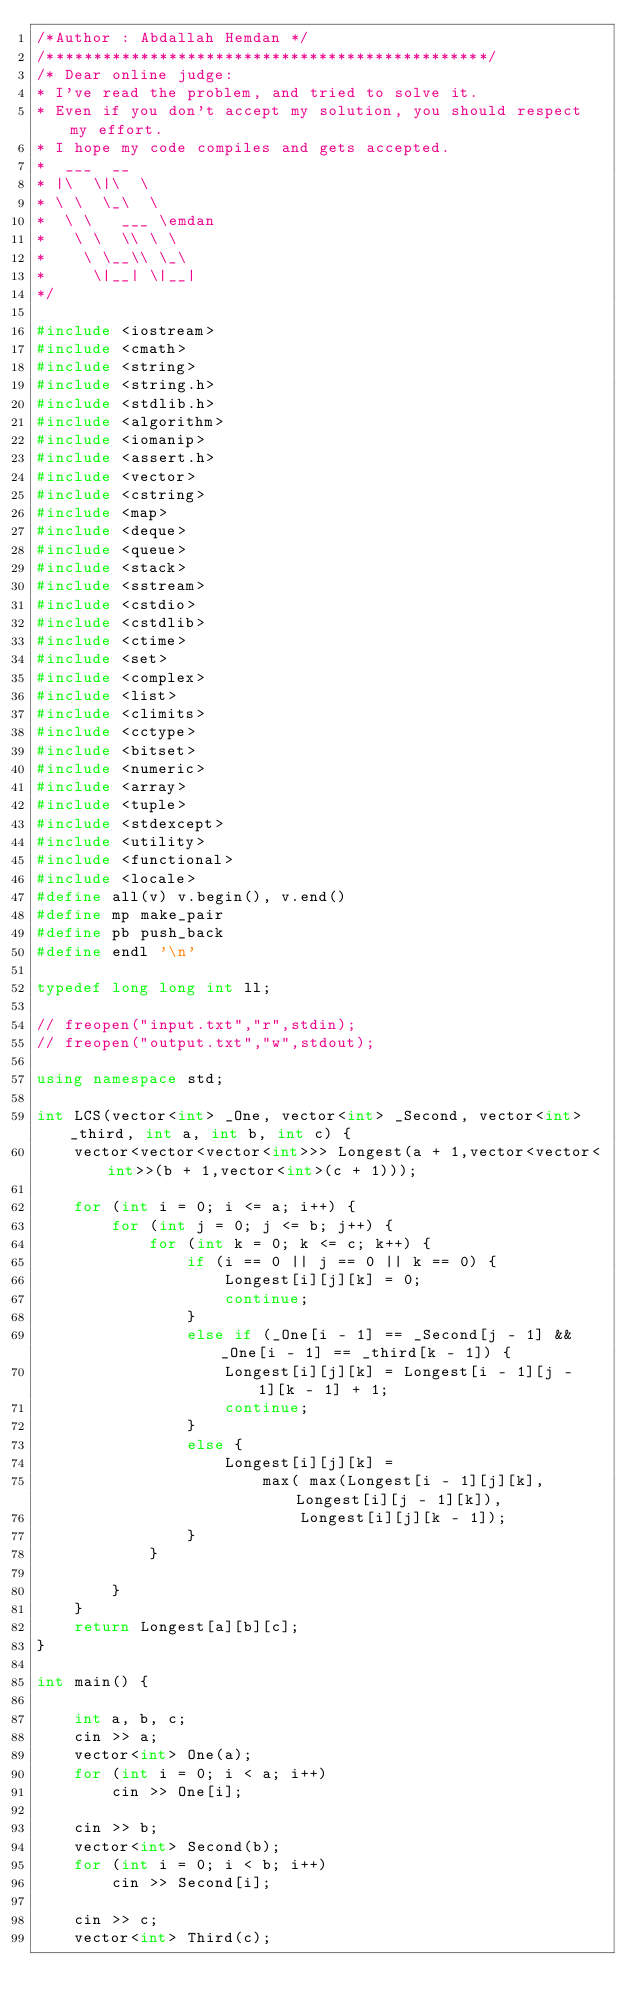<code> <loc_0><loc_0><loc_500><loc_500><_C++_>/*Author : Abdallah Hemdan */
/***********************************************/
/* Dear online judge:
* I've read the problem, and tried to solve it.
* Even if you don't accept my solution, you should respect my effort.
* I hope my code compiles and gets accepted.
*  ___  __
* |\  \|\  \
* \ \  \_\  \
*  \ \   ___ \emdan
*   \ \  \\ \ \
*    \ \__\\ \_\
*     \|__| \|__|
*/

#include <iostream>
#include <cmath>
#include <string>
#include <string.h>
#include <stdlib.h>
#include <algorithm>
#include <iomanip>
#include <assert.h>
#include <vector>
#include <cstring>
#include <map>
#include <deque>
#include <queue>
#include <stack>
#include <sstream>
#include <cstdio>
#include <cstdlib>
#include <ctime>
#include <set>
#include <complex>
#include <list>
#include <climits>
#include <cctype>
#include <bitset>
#include <numeric>
#include <array>
#include <tuple>
#include <stdexcept>
#include <utility>
#include <functional>
#include <locale>
#define all(v) v.begin(), v.end()
#define mp make_pair
#define pb push_back
#define endl '\n'

typedef long long int ll;

// freopen("input.txt","r",stdin);
// freopen("output.txt","w",stdout);

using namespace std;

int LCS(vector<int> _One, vector<int> _Second, vector<int> _third, int a, int b, int c) {
	vector<vector<vector<int>>> Longest(a + 1,vector<vector<int>>(b + 1,vector<int>(c + 1)));

	for (int i = 0; i <= a; i++) {
		for (int j = 0; j <= b; j++) {
			for (int k = 0; k <= c; k++) {
				if (i == 0 || j == 0 || k == 0) {
					Longest[i][j][k] = 0;
					continue;
				}
				else if (_One[i - 1] == _Second[j - 1] && _One[i - 1] == _third[k - 1]) {
					Longest[i][j][k] = Longest[i - 1][j - 1][k - 1] + 1;
					continue;
				}
				else {
					Longest[i][j][k] =
						max( max(Longest[i - 1][j][k], Longest[i][j - 1][k]),
							Longest[i][j][k - 1]);
				}
			}

		}
	}
	return Longest[a][b][c];
}

int main() {

	int a, b, c;
	cin >> a;
	vector<int> One(a);
	for (int i = 0; i < a; i++)
		cin >> One[i];

	cin >> b;
	vector<int> Second(b);
	for (int i = 0; i < b; i++) 
		cin >> Second[i];

	cin >> c;
	vector<int> Third(c);</code> 